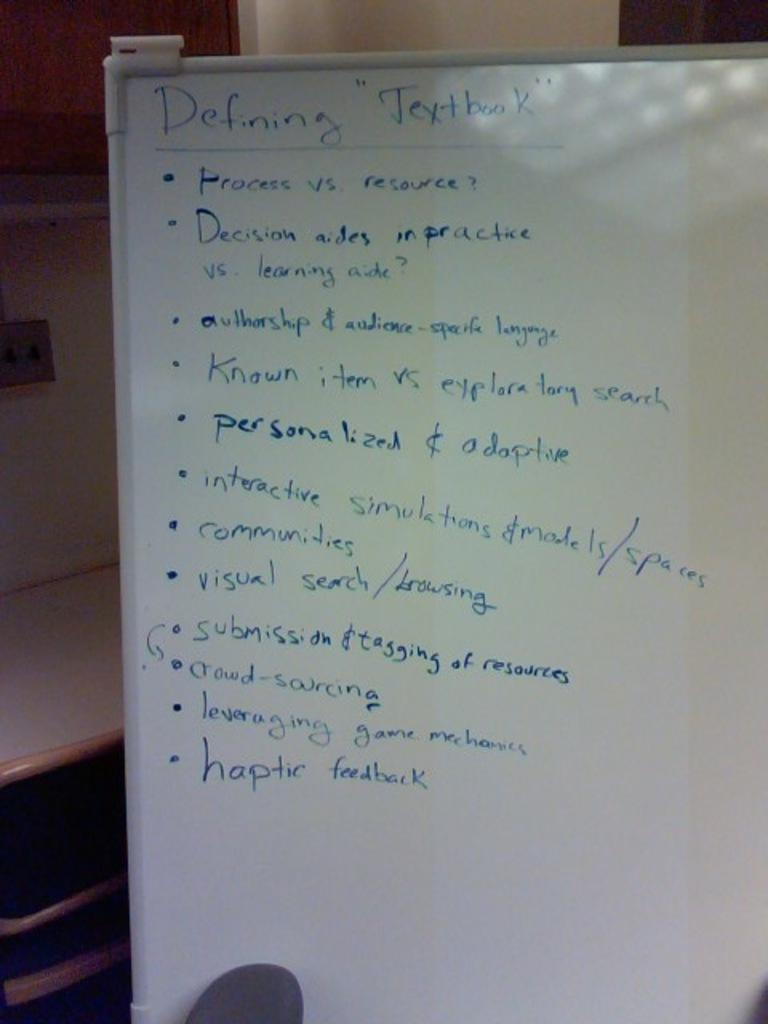<image>
Create a compact narrative representing the image presented. Whiteboard with the title of "Defining Textbook" on the top. 